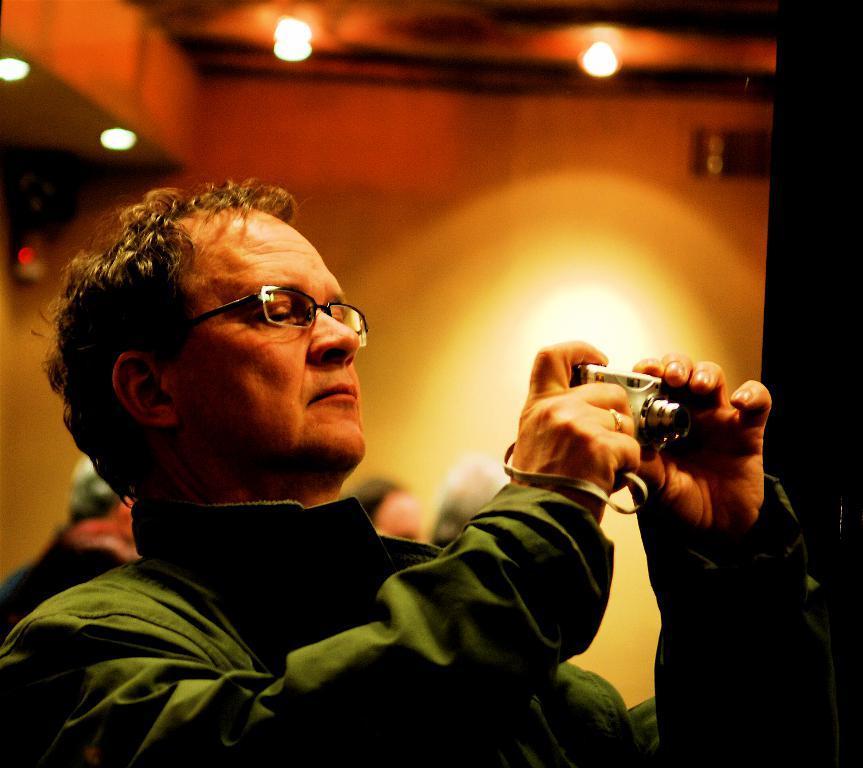How would you summarize this image in a sentence or two? The man in green jacket who is wearing spectacles is holding a camera in his hand and he is clicking photos on the camera. Behind him, we see a wall and at the top of the picture, we see the lights and the ceiling of the room. This picture is clicked inside the room. In the background, it is blurred. 